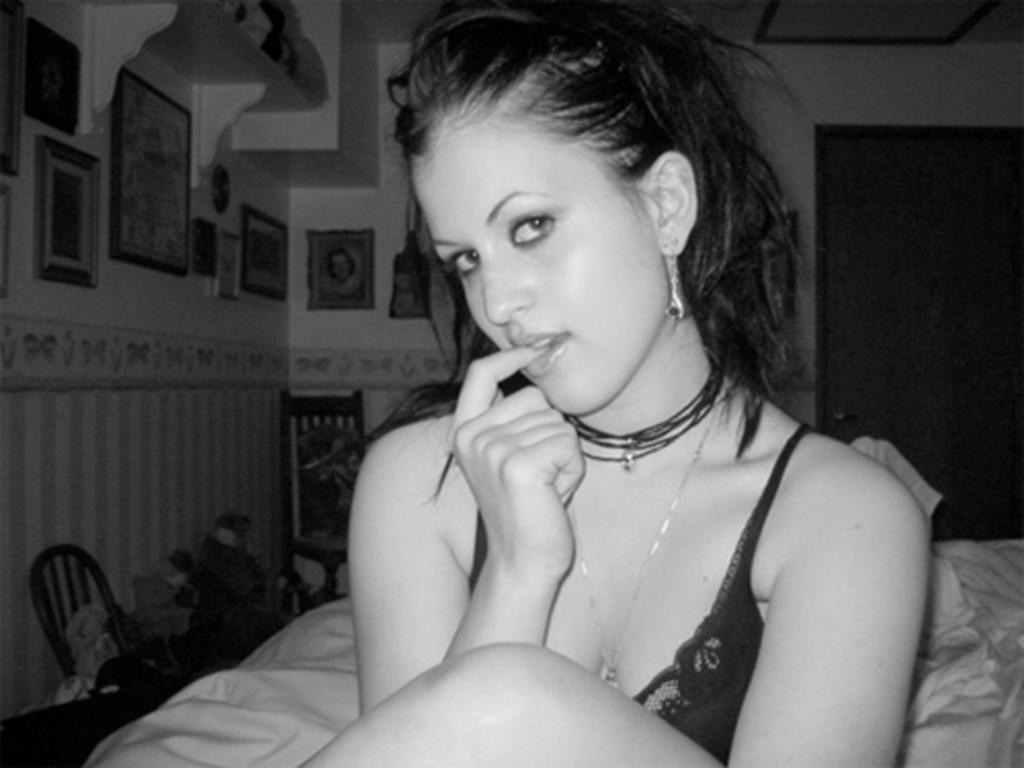What is the color scheme of the image? The image is black and white. Who is present in the image? There is a woman in the image. What type of material is visible in the image? There is cloth in the image. What piece of furniture can be seen in the image? There is a chair in the image. Can you describe the background of the image? There is a wall, a door, and frames in the background of the image. What is the condition of the fact in the image? There is no fact present in the image, and therefore no condition can be determined. What type of selection is depicted in the image? There is no selection depicted in the image; it features a woman, cloth, a chair, and a background with a wall, a door, and frames. 